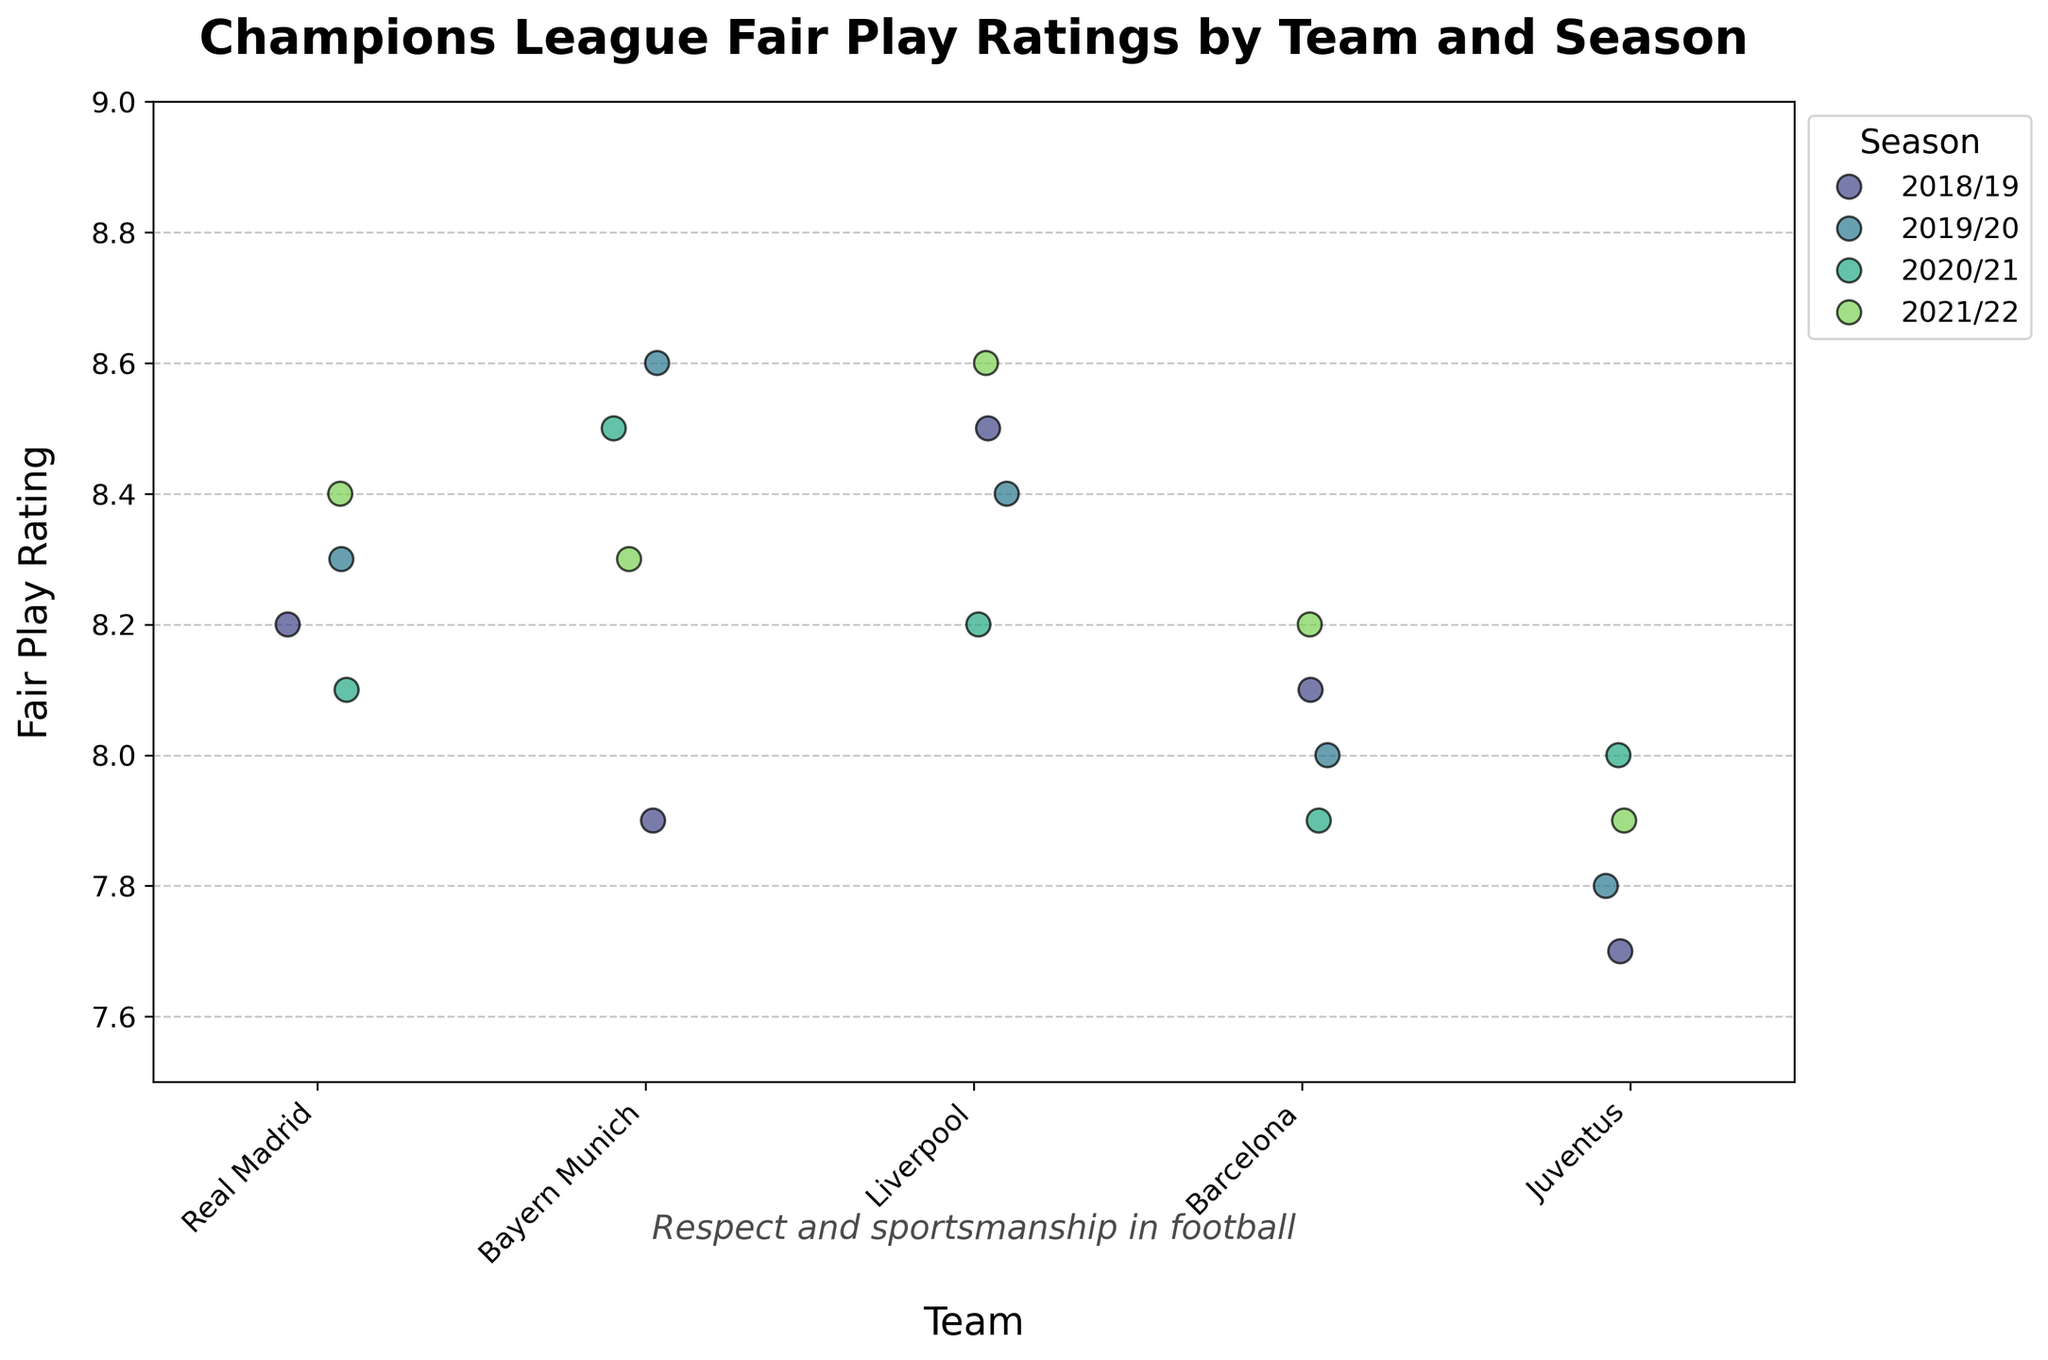What is the title of the plot? The title of the plot is displayed at the top of the figure and is meant to provide a summary of what the plot represents.
Answer: Champions League Fair Play Ratings by Team and Season Which team has the highest fair play rating in the 2018/19 season? The team with the highest fair play rating in the 2018/19 season can be identified by looking at the points for that season (indicated by color) in the plot and finding the highest value.
Answer: Liverpool Did any team's fair play rating improve every season? To determine if any team's fair play rating improved every season, examine the fair play ratings for each team across different seasons and check for an upward trend.
Answer: No What is the overall range of fair play ratings displayed in the plot? The range of fair play ratings is determined by identifying the minimum and maximum values on the y-axis of the plot. The plot ranges from 7.5 to 9.0.
Answer: 7.7 to 8.6 Which team had the lowest fair play rating in the 2021/22 season? To find the team with the lowest fair play rating in the 2021/22 season, examine the points for that season (indicated by color) in the plot and identify the lowest value.
Answer: Juventus How does the fair play rating of Bayern Munich compare between the 2018/19 and 2019/20 seasons? To compare the fair play rating of Bayern Munich between the 2018/19 and 2019/20 seasons, check the values for these seasons and see if they increased, decreased, or remained the same.
Answer: Increased Which team has the most consistent fair play rating across all seasons? Consistency in fair play rating can be identified by checking which team has the least variability in their ratings over all the seasons.
Answer: Liverpool Is there a season where all teams' fair play ratings fall between any specific range? To determine if there is a season where all teams' fair play ratings fall within a specific range, examine each season's ratings and ensure all points fall within that range.
Answer: Yes, 2019/20 (7.8 to 8.6) What can be inferred about fair play ratings and their stability over multiple seasons in the plot? To infer about stability, observe the fair play ratings' fluctuations over seasons and check for patterns or consistency over time.
Answer: Fair play ratings are generally stable with minor variations 